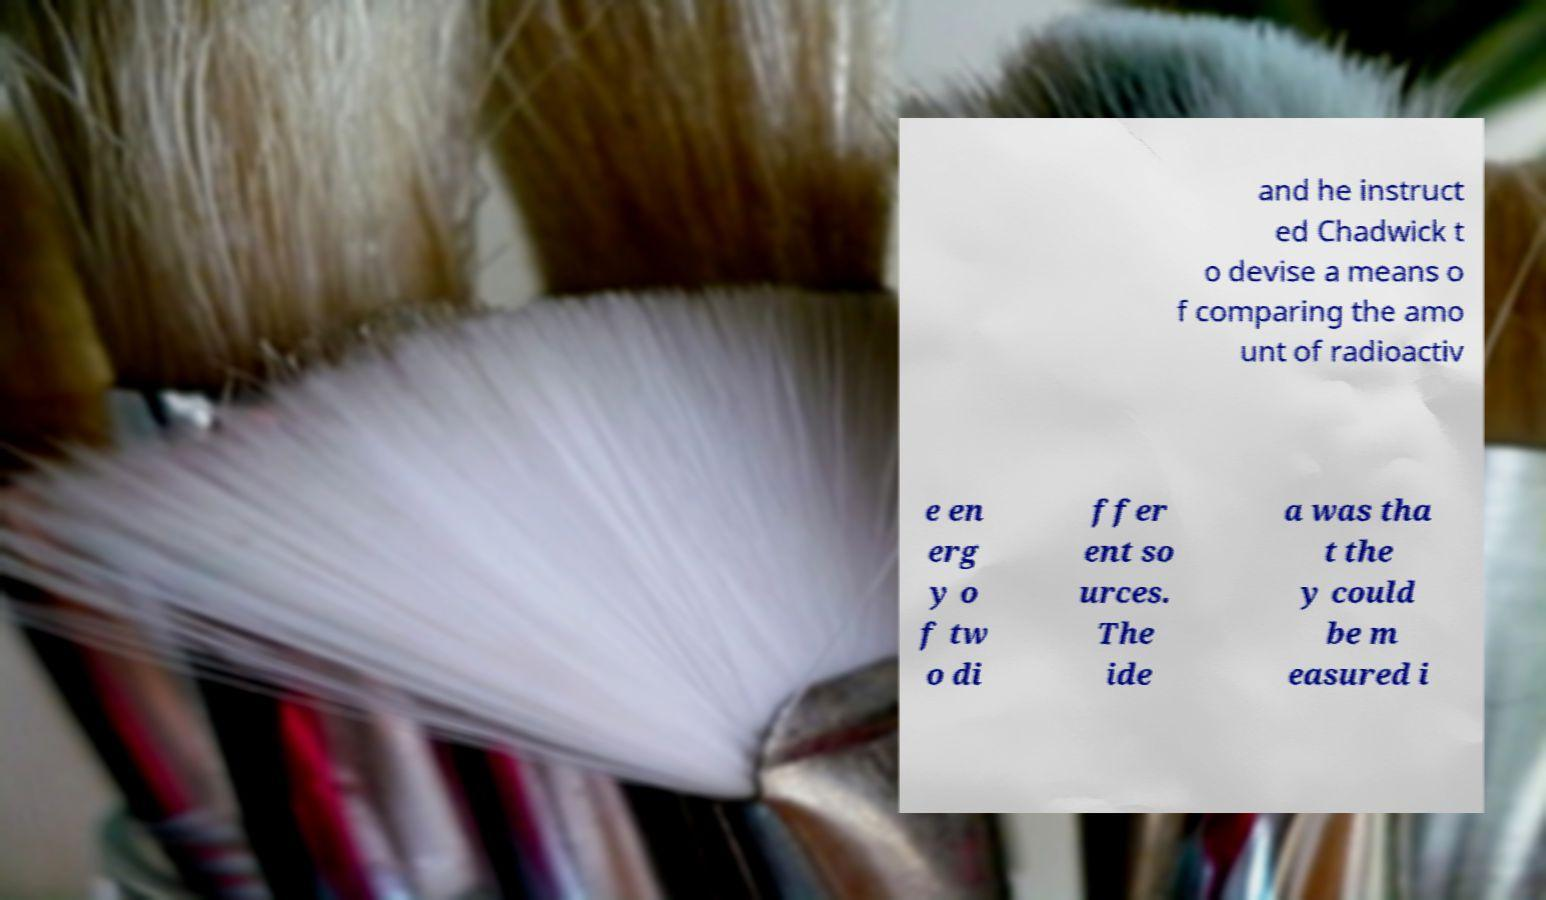Can you accurately transcribe the text from the provided image for me? and he instruct ed Chadwick t o devise a means o f comparing the amo unt of radioactiv e en erg y o f tw o di ffer ent so urces. The ide a was tha t the y could be m easured i 